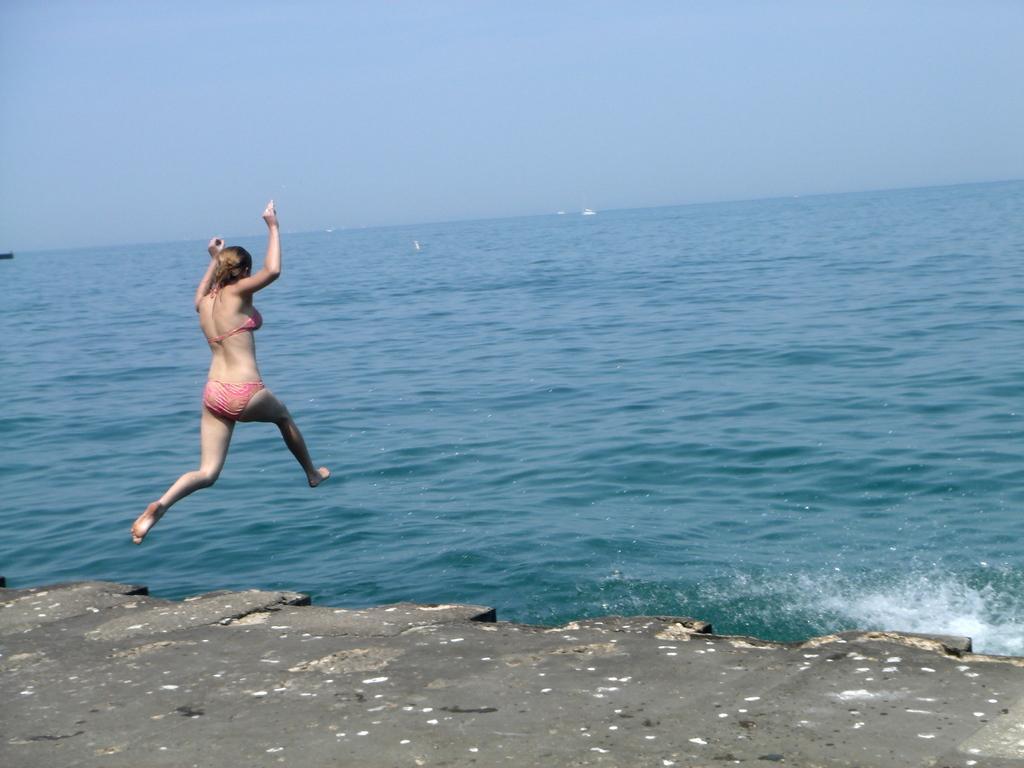Please provide a concise description of this image. In this image we can see lady jumping into the water. In the background there is sky. 